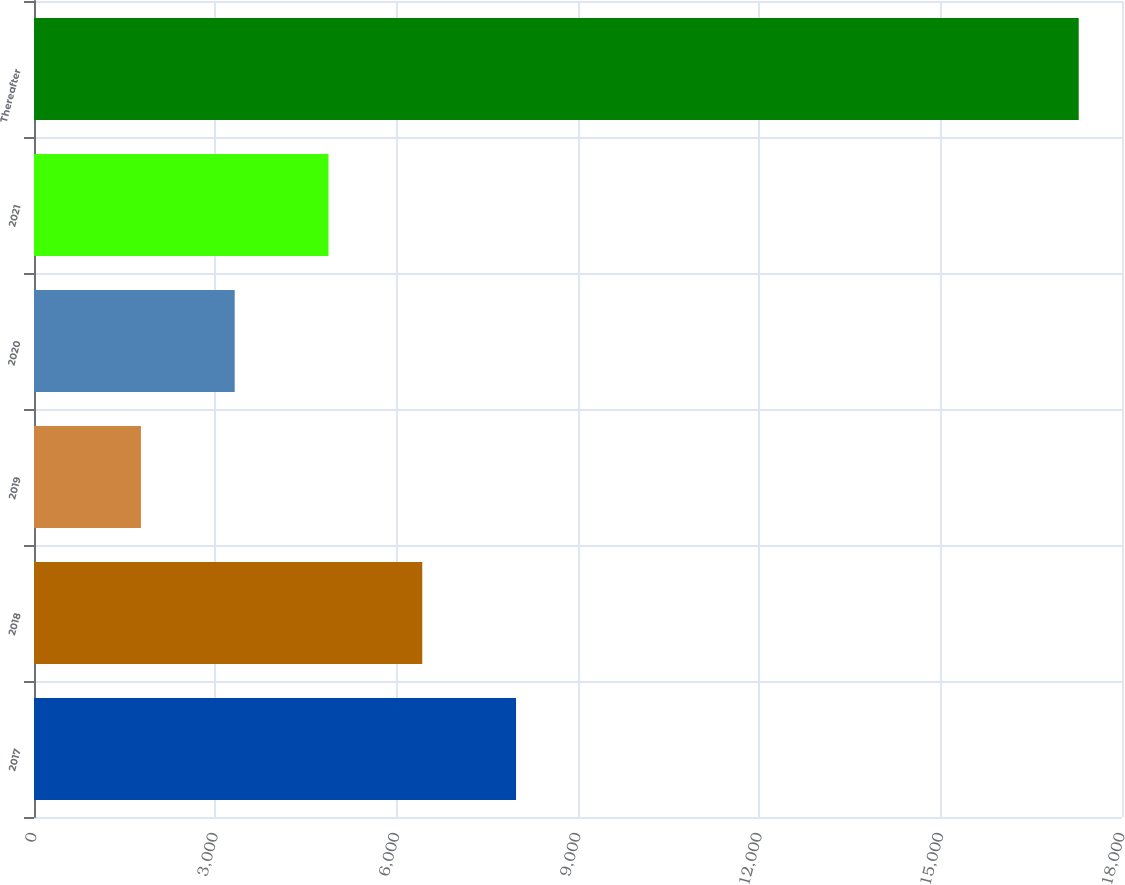Convert chart to OTSL. <chart><loc_0><loc_0><loc_500><loc_500><bar_chart><fcel>2017<fcel>2018<fcel>2019<fcel>2020<fcel>2021<fcel>Thereafter<nl><fcel>7975<fcel>6423.5<fcel>1769<fcel>3320.5<fcel>4872<fcel>17284<nl></chart> 